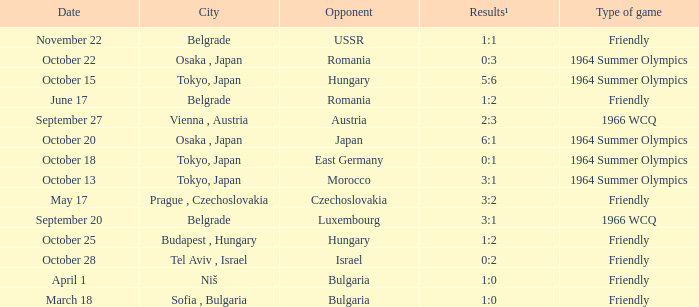What was the opponent on october 28? Israel. 